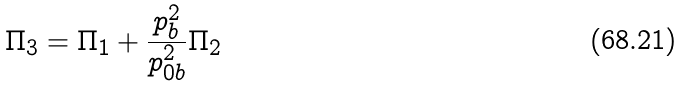Convert formula to latex. <formula><loc_0><loc_0><loc_500><loc_500>\Pi _ { 3 } = \Pi _ { 1 } + { \frac { p _ { b } ^ { 2 } } { p _ { 0 b } ^ { 2 } } } \Pi _ { 2 }</formula> 